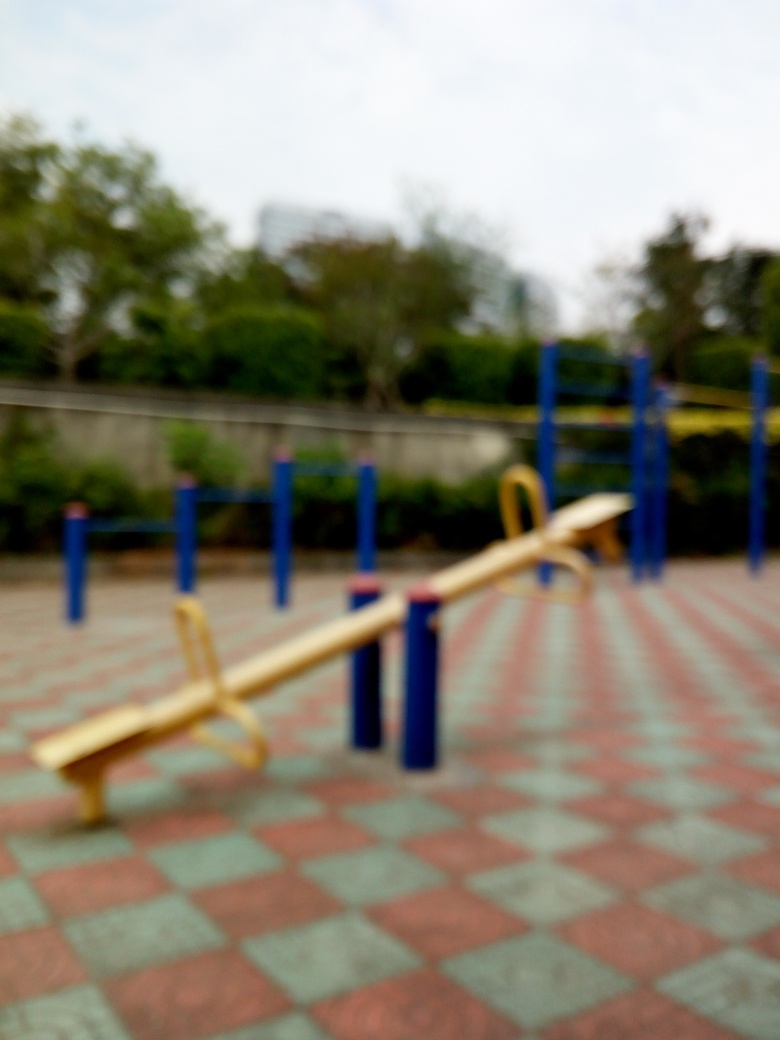Can you tell me more about the design and color scheme of the playground equipment in the image? Certainly! The playground equipment, which includes a seesaw, features a vibrant color scheme with yellow seats and handles that provide a nice contrast against the blue support bars. Such colors are often chosen for playground equipment because they are bright and attractive to children, stimulating their visual senses and inviting them to play. 